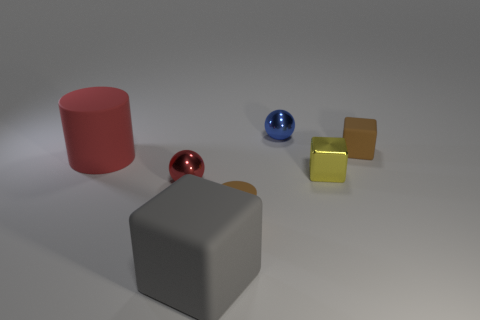Add 1 small matte blocks. How many objects exist? 8 Subtract all brown cubes. How many cubes are left? 2 Subtract 1 blocks. How many blocks are left? 2 Subtract all cylinders. How many objects are left? 5 Subtract 0 green cylinders. How many objects are left? 7 Subtract all cyan blocks. Subtract all cyan cylinders. How many blocks are left? 3 Subtract all yellow things. Subtract all large things. How many objects are left? 4 Add 4 tiny matte cubes. How many tiny matte cubes are left? 5 Add 1 cyan cylinders. How many cyan cylinders exist? 1 